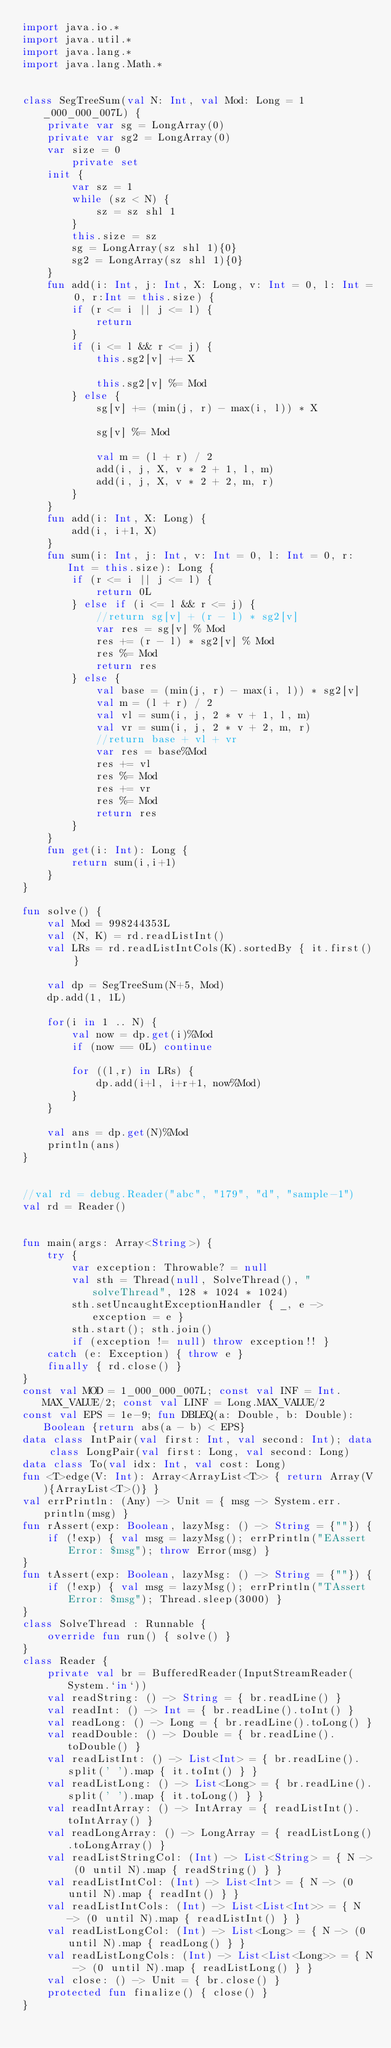<code> <loc_0><loc_0><loc_500><loc_500><_Kotlin_>import java.io.*
import java.util.*
import java.lang.*
import java.lang.Math.*


class SegTreeSum(val N: Int, val Mod: Long = 1_000_000_007L) {
    private var sg = LongArray(0)
    private var sg2 = LongArray(0)
    var size = 0
        private set
    init {
        var sz = 1
        while (sz < N) {
            sz = sz shl 1
        }
        this.size = sz
        sg = LongArray(sz shl 1){0}
        sg2 = LongArray(sz shl 1){0}
    }
    fun add(i: Int, j: Int, X: Long, v: Int = 0, l: Int = 0, r:Int = this.size) {
        if (r <= i || j <= l) {
            return
        }
        if (i <= l && r <= j) {
            this.sg2[v] += X

            this.sg2[v] %= Mod
        } else {
            sg[v] += (min(j, r) - max(i, l)) * X

            sg[v] %= Mod

            val m = (l + r) / 2
            add(i, j, X, v * 2 + 1, l, m)
            add(i, j, X, v * 2 + 2, m, r)
        }
    }
    fun add(i: Int, X: Long) {
        add(i, i+1, X)
    }
    fun sum(i: Int, j: Int, v: Int = 0, l: Int = 0, r: Int = this.size): Long {
        if (r <= i || j <= l) {
            return 0L
        } else if (i <= l && r <= j) {
            //return sg[v] + (r - l) * sg2[v]
            var res = sg[v] % Mod
            res += (r - l) * sg2[v] % Mod
            res %= Mod
            return res
        } else {
            val base = (min(j, r) - max(i, l)) * sg2[v]
            val m = (l + r) / 2
            val vl = sum(i, j, 2 * v + 1, l, m)
            val vr = sum(i, j, 2 * v + 2, m, r)
            //return base + vl + vr
            var res = base%Mod
            res += vl
            res %= Mod
            res += vr
            res %= Mod
            return res
        }
    }
    fun get(i: Int): Long {
        return sum(i,i+1)
    }
}

fun solve() {
    val Mod = 998244353L
    val (N, K) = rd.readListInt()
    val LRs = rd.readListIntCols(K).sortedBy { it.first() }
    
    val dp = SegTreeSum(N+5, Mod)
    dp.add(1, 1L)

    for(i in 1 .. N) {
        val now = dp.get(i)%Mod
        if (now == 0L) continue
        
        for ((l,r) in LRs) {
            dp.add(i+l, i+r+1, now%Mod)
        }
    }

    val ans = dp.get(N)%Mod
    println(ans)
}


//val rd = debug.Reader("abc", "179", "d", "sample-1")
val rd = Reader()


fun main(args: Array<String>) {
    try {
        var exception: Throwable? = null
        val sth = Thread(null, SolveThread(), "solveThread", 128 * 1024 * 1024)
        sth.setUncaughtExceptionHandler { _, e -> exception = e }
        sth.start(); sth.join()
        if (exception != null) throw exception!! }
    catch (e: Exception) { throw e }
    finally { rd.close() }
}
const val MOD = 1_000_000_007L; const val INF = Int.MAX_VALUE/2; const val LINF = Long.MAX_VALUE/2
const val EPS = 1e-9; fun DBLEQ(a: Double, b: Double): Boolean {return abs(a - b) < EPS}
data class IntPair(val first: Int, val second: Int); data class LongPair(val first: Long, val second: Long)
data class To(val idx: Int, val cost: Long)
fun <T>edge(V: Int): Array<ArrayList<T>> { return Array(V){ArrayList<T>()} }
val errPrintln: (Any) -> Unit = { msg -> System.err.println(msg) }
fun rAssert(exp: Boolean, lazyMsg: () -> String = {""}) {
    if (!exp) { val msg = lazyMsg(); errPrintln("EAssert Error: $msg"); throw Error(msg) }
}
fun tAssert(exp: Boolean, lazyMsg: () -> String = {""}) {
    if (!exp) { val msg = lazyMsg(); errPrintln("TAssert Error: $msg"); Thread.sleep(3000) }
}
class SolveThread : Runnable {
    override fun run() { solve() }
}
class Reader {
    private val br = BufferedReader(InputStreamReader(System.`in`))
    val readString: () -> String = { br.readLine() }
    val readInt: () -> Int = { br.readLine().toInt() }
    val readLong: () -> Long = { br.readLine().toLong() }
    val readDouble: () -> Double = { br.readLine().toDouble() }
    val readListInt: () -> List<Int> = { br.readLine().split(' ').map { it.toInt() } }
    val readListLong: () -> List<Long> = { br.readLine().split(' ').map { it.toLong() } }
    val readIntArray: () -> IntArray = { readListInt().toIntArray() }
    val readLongArray: () -> LongArray = { readListLong().toLongArray() }
    val readListStringCol: (Int) -> List<String> = { N -> (0 until N).map { readString() } }
    val readListIntCol: (Int) -> List<Int> = { N -> (0 until N).map { readInt() } }
    val readListIntCols: (Int) -> List<List<Int>> = { N -> (0 until N).map { readListInt() } }
    val readListLongCol: (Int) -> List<Long> = { N -> (0 until N).map { readLong() } }
    val readListLongCols: (Int) -> List<List<Long>> = { N -> (0 until N).map { readListLong() } }
    val close: () -> Unit = { br.close() }
    protected fun finalize() { close() }
}
</code> 